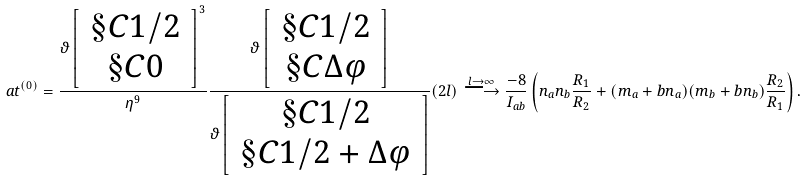Convert formula to latex. <formula><loc_0><loc_0><loc_500><loc_500>\ a t ^ { ( 0 ) } = \frac { \vartheta \left [ \, \begin{array} { c } \S C 1 / 2 \\ \S C 0 \end{array} \, \right ] ^ { 3 } } { \eta ^ { 9 } } \frac { \vartheta \left [ \, \begin{array} { c } \S C 1 / 2 \\ \S C \Delta \varphi \end{array} \, \right ] } { \vartheta \left [ \, \begin{array} { c } \S C 1 / 2 \\ \S C 1 / 2 + \Delta \varphi \end{array} \, \right ] } ( 2 l ) \stackrel { l \rightarrow \infty } { \longrightarrow } \frac { - 8 } { I _ { a b } } \left ( n _ { a } n _ { b } \frac { R _ { 1 } } { R _ { 2 } } + ( m _ { a } + b n _ { a } ) ( m _ { b } + b n _ { b } ) \frac { R _ { 2 } } { R _ { 1 } } \right ) .</formula> 